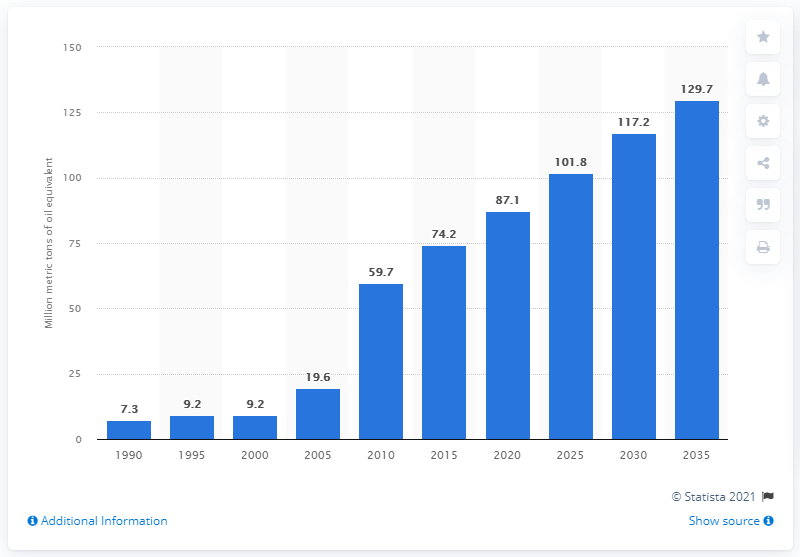List a handful of essential elements in this visual. It is projected that global consumption of biofuels will reach its peak in 2035. According to data from 1990, the global consumption of biofuels was approximately 7.3 million metric tons. 